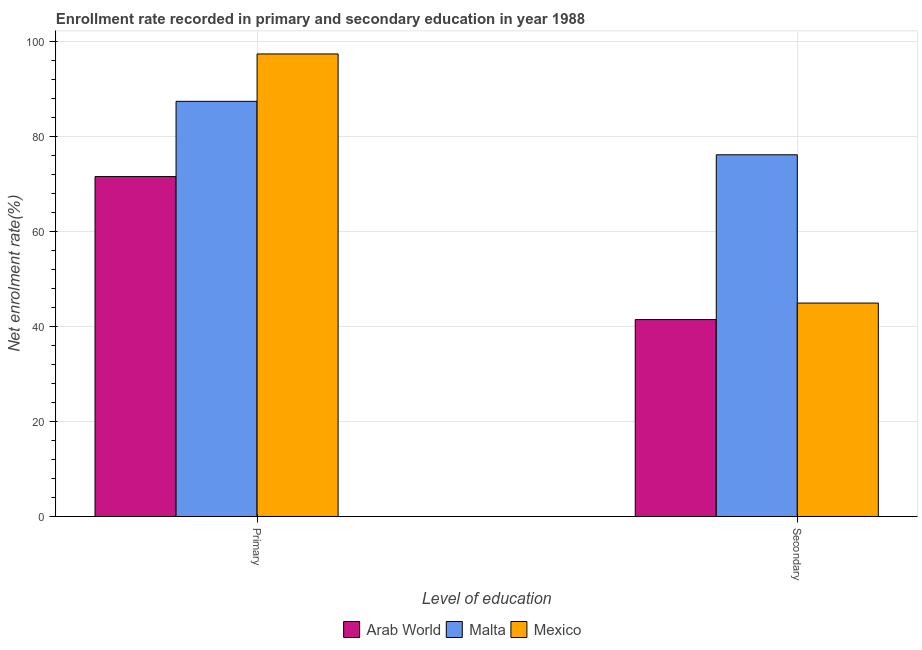How many different coloured bars are there?
Offer a very short reply. 3. Are the number of bars on each tick of the X-axis equal?
Make the answer very short. Yes. How many bars are there on the 1st tick from the left?
Your answer should be compact. 3. What is the label of the 1st group of bars from the left?
Your answer should be very brief. Primary. What is the enrollment rate in secondary education in Arab World?
Provide a short and direct response. 41.43. Across all countries, what is the maximum enrollment rate in secondary education?
Keep it short and to the point. 76.1. Across all countries, what is the minimum enrollment rate in secondary education?
Your answer should be compact. 41.43. In which country was the enrollment rate in secondary education minimum?
Ensure brevity in your answer.  Arab World. What is the total enrollment rate in primary education in the graph?
Offer a terse response. 256.15. What is the difference between the enrollment rate in secondary education in Malta and that in Mexico?
Your answer should be very brief. 31.19. What is the difference between the enrollment rate in secondary education in Malta and the enrollment rate in primary education in Mexico?
Your response must be concise. -21.21. What is the average enrollment rate in secondary education per country?
Offer a very short reply. 54.14. What is the difference between the enrollment rate in primary education and enrollment rate in secondary education in Malta?
Your answer should be very brief. 11.24. In how many countries, is the enrollment rate in primary education greater than 96 %?
Your response must be concise. 1. What is the ratio of the enrollment rate in primary education in Mexico to that in Malta?
Offer a very short reply. 1.11. Is the enrollment rate in secondary education in Mexico less than that in Arab World?
Your response must be concise. No. What does the 1st bar from the left in Secondary represents?
Offer a very short reply. Arab World. What does the 1st bar from the right in Primary represents?
Give a very brief answer. Mexico. How many bars are there?
Offer a terse response. 6. Are the values on the major ticks of Y-axis written in scientific E-notation?
Keep it short and to the point. No. Does the graph contain any zero values?
Provide a succinct answer. No. Does the graph contain grids?
Offer a very short reply. Yes. How many legend labels are there?
Ensure brevity in your answer.  3. What is the title of the graph?
Your response must be concise. Enrollment rate recorded in primary and secondary education in year 1988. Does "Low & middle income" appear as one of the legend labels in the graph?
Your answer should be compact. No. What is the label or title of the X-axis?
Ensure brevity in your answer.  Level of education. What is the label or title of the Y-axis?
Your response must be concise. Net enrolment rate(%). What is the Net enrolment rate(%) of Arab World in Primary?
Make the answer very short. 71.51. What is the Net enrolment rate(%) in Malta in Primary?
Offer a terse response. 87.34. What is the Net enrolment rate(%) in Mexico in Primary?
Offer a terse response. 97.3. What is the Net enrolment rate(%) in Arab World in Secondary?
Your answer should be very brief. 41.43. What is the Net enrolment rate(%) of Malta in Secondary?
Provide a succinct answer. 76.1. What is the Net enrolment rate(%) of Mexico in Secondary?
Offer a very short reply. 44.91. Across all Level of education, what is the maximum Net enrolment rate(%) in Arab World?
Ensure brevity in your answer.  71.51. Across all Level of education, what is the maximum Net enrolment rate(%) of Malta?
Offer a terse response. 87.34. Across all Level of education, what is the maximum Net enrolment rate(%) in Mexico?
Offer a terse response. 97.3. Across all Level of education, what is the minimum Net enrolment rate(%) of Arab World?
Offer a terse response. 41.43. Across all Level of education, what is the minimum Net enrolment rate(%) in Malta?
Give a very brief answer. 76.1. Across all Level of education, what is the minimum Net enrolment rate(%) of Mexico?
Offer a terse response. 44.91. What is the total Net enrolment rate(%) in Arab World in the graph?
Offer a terse response. 112.94. What is the total Net enrolment rate(%) in Malta in the graph?
Give a very brief answer. 163.43. What is the total Net enrolment rate(%) of Mexico in the graph?
Your answer should be very brief. 142.21. What is the difference between the Net enrolment rate(%) in Arab World in Primary and that in Secondary?
Make the answer very short. 30.08. What is the difference between the Net enrolment rate(%) of Malta in Primary and that in Secondary?
Make the answer very short. 11.24. What is the difference between the Net enrolment rate(%) in Mexico in Primary and that in Secondary?
Make the answer very short. 52.4. What is the difference between the Net enrolment rate(%) of Arab World in Primary and the Net enrolment rate(%) of Malta in Secondary?
Ensure brevity in your answer.  -4.59. What is the difference between the Net enrolment rate(%) in Arab World in Primary and the Net enrolment rate(%) in Mexico in Secondary?
Give a very brief answer. 26.61. What is the difference between the Net enrolment rate(%) of Malta in Primary and the Net enrolment rate(%) of Mexico in Secondary?
Offer a terse response. 42.43. What is the average Net enrolment rate(%) in Arab World per Level of education?
Provide a short and direct response. 56.47. What is the average Net enrolment rate(%) of Malta per Level of education?
Provide a succinct answer. 81.72. What is the average Net enrolment rate(%) of Mexico per Level of education?
Ensure brevity in your answer.  71.1. What is the difference between the Net enrolment rate(%) in Arab World and Net enrolment rate(%) in Malta in Primary?
Give a very brief answer. -15.83. What is the difference between the Net enrolment rate(%) in Arab World and Net enrolment rate(%) in Mexico in Primary?
Ensure brevity in your answer.  -25.79. What is the difference between the Net enrolment rate(%) of Malta and Net enrolment rate(%) of Mexico in Primary?
Offer a very short reply. -9.97. What is the difference between the Net enrolment rate(%) in Arab World and Net enrolment rate(%) in Malta in Secondary?
Offer a terse response. -34.67. What is the difference between the Net enrolment rate(%) in Arab World and Net enrolment rate(%) in Mexico in Secondary?
Ensure brevity in your answer.  -3.48. What is the difference between the Net enrolment rate(%) in Malta and Net enrolment rate(%) in Mexico in Secondary?
Make the answer very short. 31.19. What is the ratio of the Net enrolment rate(%) in Arab World in Primary to that in Secondary?
Your response must be concise. 1.73. What is the ratio of the Net enrolment rate(%) of Malta in Primary to that in Secondary?
Your answer should be compact. 1.15. What is the ratio of the Net enrolment rate(%) of Mexico in Primary to that in Secondary?
Make the answer very short. 2.17. What is the difference between the highest and the second highest Net enrolment rate(%) of Arab World?
Your answer should be very brief. 30.08. What is the difference between the highest and the second highest Net enrolment rate(%) of Malta?
Offer a terse response. 11.24. What is the difference between the highest and the second highest Net enrolment rate(%) in Mexico?
Provide a short and direct response. 52.4. What is the difference between the highest and the lowest Net enrolment rate(%) of Arab World?
Your answer should be compact. 30.08. What is the difference between the highest and the lowest Net enrolment rate(%) in Malta?
Your answer should be compact. 11.24. What is the difference between the highest and the lowest Net enrolment rate(%) of Mexico?
Provide a short and direct response. 52.4. 